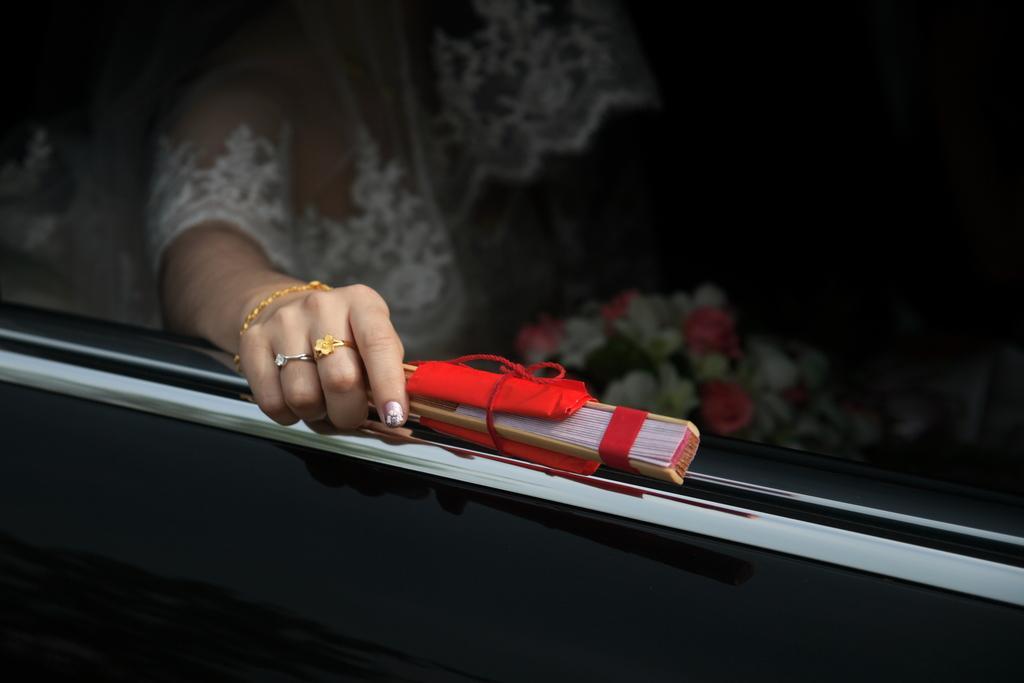Describe this image in one or two sentences. In this image there is one vehicle in that vehicle there is one woman who is sitting, and she is holding a flower bouquet and some sticks. 